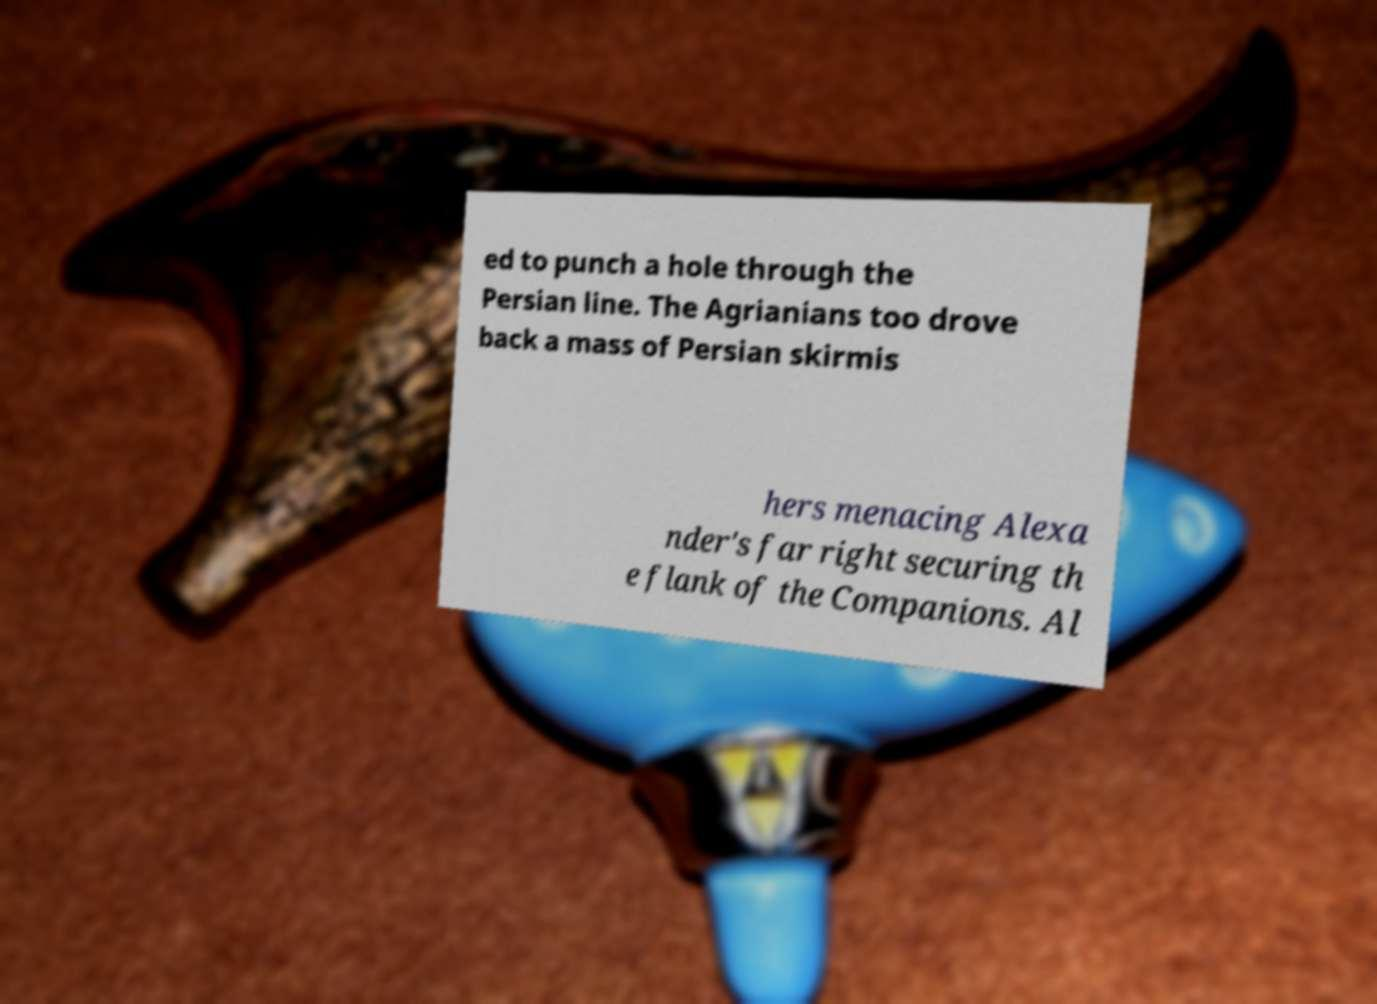Can you accurately transcribe the text from the provided image for me? ed to punch a hole through the Persian line. The Agrianians too drove back a mass of Persian skirmis hers menacing Alexa nder's far right securing th e flank of the Companions. Al 